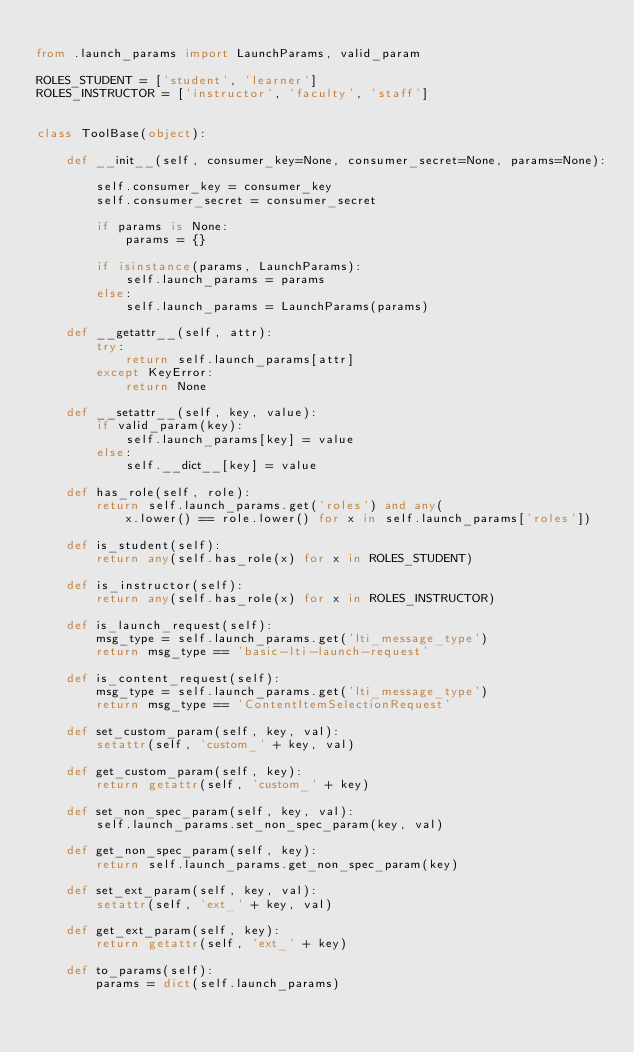Convert code to text. <code><loc_0><loc_0><loc_500><loc_500><_Python_>
from .launch_params import LaunchParams, valid_param

ROLES_STUDENT = ['student', 'learner']
ROLES_INSTRUCTOR = ['instructor', 'faculty', 'staff']


class ToolBase(object):

    def __init__(self, consumer_key=None, consumer_secret=None, params=None):

        self.consumer_key = consumer_key
        self.consumer_secret = consumer_secret

        if params is None:
            params = {}

        if isinstance(params, LaunchParams):
            self.launch_params = params
        else:
            self.launch_params = LaunchParams(params)

    def __getattr__(self, attr):
        try:
            return self.launch_params[attr]
        except KeyError:
            return None

    def __setattr__(self, key, value):
        if valid_param(key):
            self.launch_params[key] = value
        else:
            self.__dict__[key] = value

    def has_role(self, role):
        return self.launch_params.get('roles') and any(
            x.lower() == role.lower() for x in self.launch_params['roles'])

    def is_student(self):
        return any(self.has_role(x) for x in ROLES_STUDENT)

    def is_instructor(self):
        return any(self.has_role(x) for x in ROLES_INSTRUCTOR)

    def is_launch_request(self):
        msg_type = self.launch_params.get('lti_message_type')
        return msg_type == 'basic-lti-launch-request'

    def is_content_request(self):
        msg_type = self.launch_params.get('lti_message_type')
        return msg_type == 'ContentItemSelectionRequest'

    def set_custom_param(self, key, val):
        setattr(self, 'custom_' + key, val)

    def get_custom_param(self, key):
        return getattr(self, 'custom_' + key)

    def set_non_spec_param(self, key, val):
        self.launch_params.set_non_spec_param(key, val)

    def get_non_spec_param(self, key):
        return self.launch_params.get_non_spec_param(key)

    def set_ext_param(self, key, val):
        setattr(self, 'ext_' + key, val)

    def get_ext_param(self, key):
        return getattr(self, 'ext_' + key)

    def to_params(self):
        params = dict(self.launch_params)</code> 